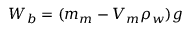Convert formula to latex. <formula><loc_0><loc_0><loc_500><loc_500>W _ { b } = ( m _ { m } - V _ { m } \rho _ { w } ) g</formula> 